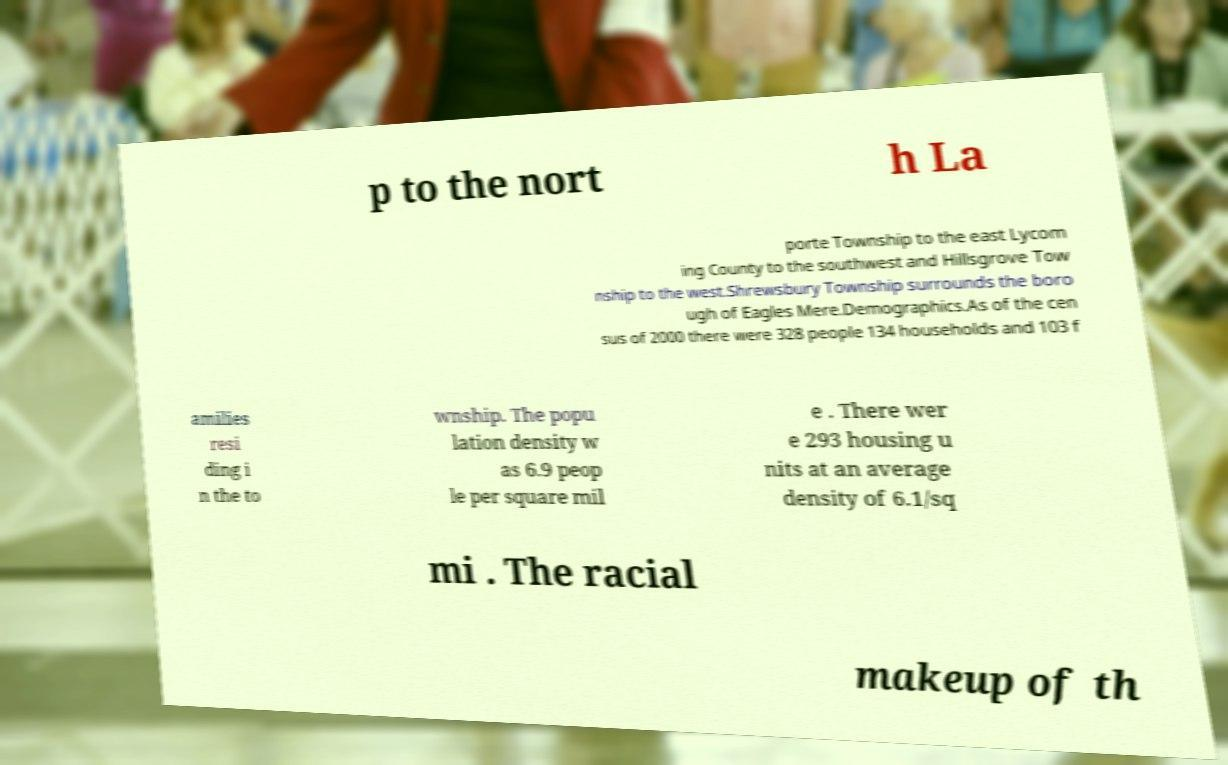I need the written content from this picture converted into text. Can you do that? p to the nort h La porte Township to the east Lycom ing County to the southwest and Hillsgrove Tow nship to the west.Shrewsbury Township surrounds the boro ugh of Eagles Mere.Demographics.As of the cen sus of 2000 there were 328 people 134 households and 103 f amilies resi ding i n the to wnship. The popu lation density w as 6.9 peop le per square mil e . There wer e 293 housing u nits at an average density of 6.1/sq mi . The racial makeup of th 